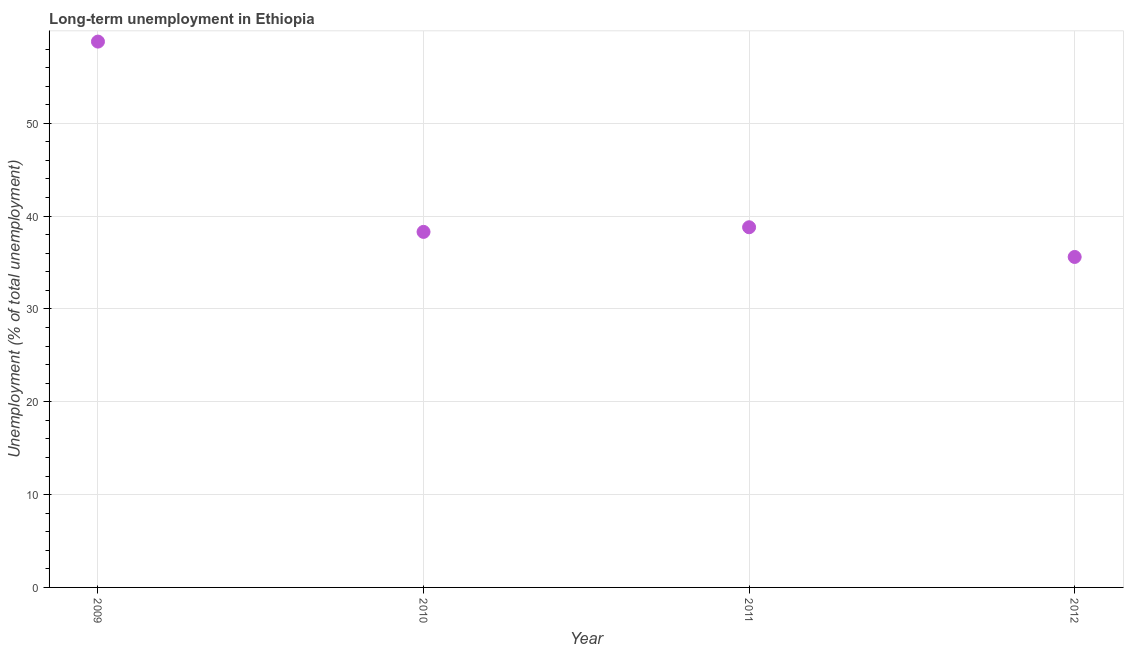What is the long-term unemployment in 2009?
Your answer should be compact. 58.8. Across all years, what is the maximum long-term unemployment?
Ensure brevity in your answer.  58.8. Across all years, what is the minimum long-term unemployment?
Your answer should be very brief. 35.6. In which year was the long-term unemployment maximum?
Provide a short and direct response. 2009. In which year was the long-term unemployment minimum?
Your response must be concise. 2012. What is the sum of the long-term unemployment?
Provide a succinct answer. 171.5. What is the difference between the long-term unemployment in 2009 and 2012?
Offer a very short reply. 23.2. What is the average long-term unemployment per year?
Your response must be concise. 42.87. What is the median long-term unemployment?
Give a very brief answer. 38.55. What is the ratio of the long-term unemployment in 2009 to that in 2012?
Make the answer very short. 1.65. Is the long-term unemployment in 2010 less than that in 2012?
Offer a very short reply. No. Is the difference between the long-term unemployment in 2011 and 2012 greater than the difference between any two years?
Your response must be concise. No. What is the difference between the highest and the second highest long-term unemployment?
Your response must be concise. 20. Is the sum of the long-term unemployment in 2009 and 2012 greater than the maximum long-term unemployment across all years?
Provide a succinct answer. Yes. What is the difference between the highest and the lowest long-term unemployment?
Provide a succinct answer. 23.2. In how many years, is the long-term unemployment greater than the average long-term unemployment taken over all years?
Provide a succinct answer. 1. How many years are there in the graph?
Give a very brief answer. 4. What is the difference between two consecutive major ticks on the Y-axis?
Provide a short and direct response. 10. Are the values on the major ticks of Y-axis written in scientific E-notation?
Make the answer very short. No. What is the title of the graph?
Keep it short and to the point. Long-term unemployment in Ethiopia. What is the label or title of the X-axis?
Offer a terse response. Year. What is the label or title of the Y-axis?
Your answer should be very brief. Unemployment (% of total unemployment). What is the Unemployment (% of total unemployment) in 2009?
Give a very brief answer. 58.8. What is the Unemployment (% of total unemployment) in 2010?
Offer a very short reply. 38.3. What is the Unemployment (% of total unemployment) in 2011?
Ensure brevity in your answer.  38.8. What is the Unemployment (% of total unemployment) in 2012?
Provide a succinct answer. 35.6. What is the difference between the Unemployment (% of total unemployment) in 2009 and 2011?
Make the answer very short. 20. What is the difference between the Unemployment (% of total unemployment) in 2009 and 2012?
Your response must be concise. 23.2. What is the difference between the Unemployment (% of total unemployment) in 2010 and 2011?
Your answer should be very brief. -0.5. What is the difference between the Unemployment (% of total unemployment) in 2010 and 2012?
Give a very brief answer. 2.7. What is the difference between the Unemployment (% of total unemployment) in 2011 and 2012?
Give a very brief answer. 3.2. What is the ratio of the Unemployment (% of total unemployment) in 2009 to that in 2010?
Keep it short and to the point. 1.53. What is the ratio of the Unemployment (% of total unemployment) in 2009 to that in 2011?
Your answer should be compact. 1.51. What is the ratio of the Unemployment (% of total unemployment) in 2009 to that in 2012?
Provide a succinct answer. 1.65. What is the ratio of the Unemployment (% of total unemployment) in 2010 to that in 2011?
Make the answer very short. 0.99. What is the ratio of the Unemployment (% of total unemployment) in 2010 to that in 2012?
Your answer should be very brief. 1.08. What is the ratio of the Unemployment (% of total unemployment) in 2011 to that in 2012?
Provide a short and direct response. 1.09. 